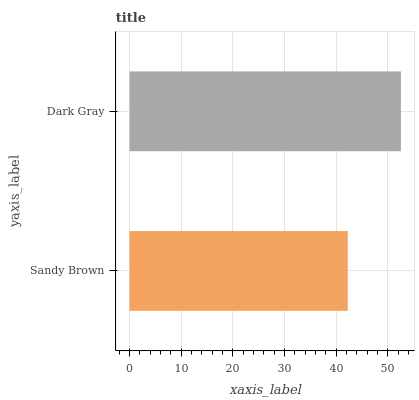Is Sandy Brown the minimum?
Answer yes or no. Yes. Is Dark Gray the maximum?
Answer yes or no. Yes. Is Dark Gray the minimum?
Answer yes or no. No. Is Dark Gray greater than Sandy Brown?
Answer yes or no. Yes. Is Sandy Brown less than Dark Gray?
Answer yes or no. Yes. Is Sandy Brown greater than Dark Gray?
Answer yes or no. No. Is Dark Gray less than Sandy Brown?
Answer yes or no. No. Is Dark Gray the high median?
Answer yes or no. Yes. Is Sandy Brown the low median?
Answer yes or no. Yes. Is Sandy Brown the high median?
Answer yes or no. No. Is Dark Gray the low median?
Answer yes or no. No. 